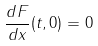<formula> <loc_0><loc_0><loc_500><loc_500>\frac { d F } { d x } ( t , 0 ) = 0</formula> 